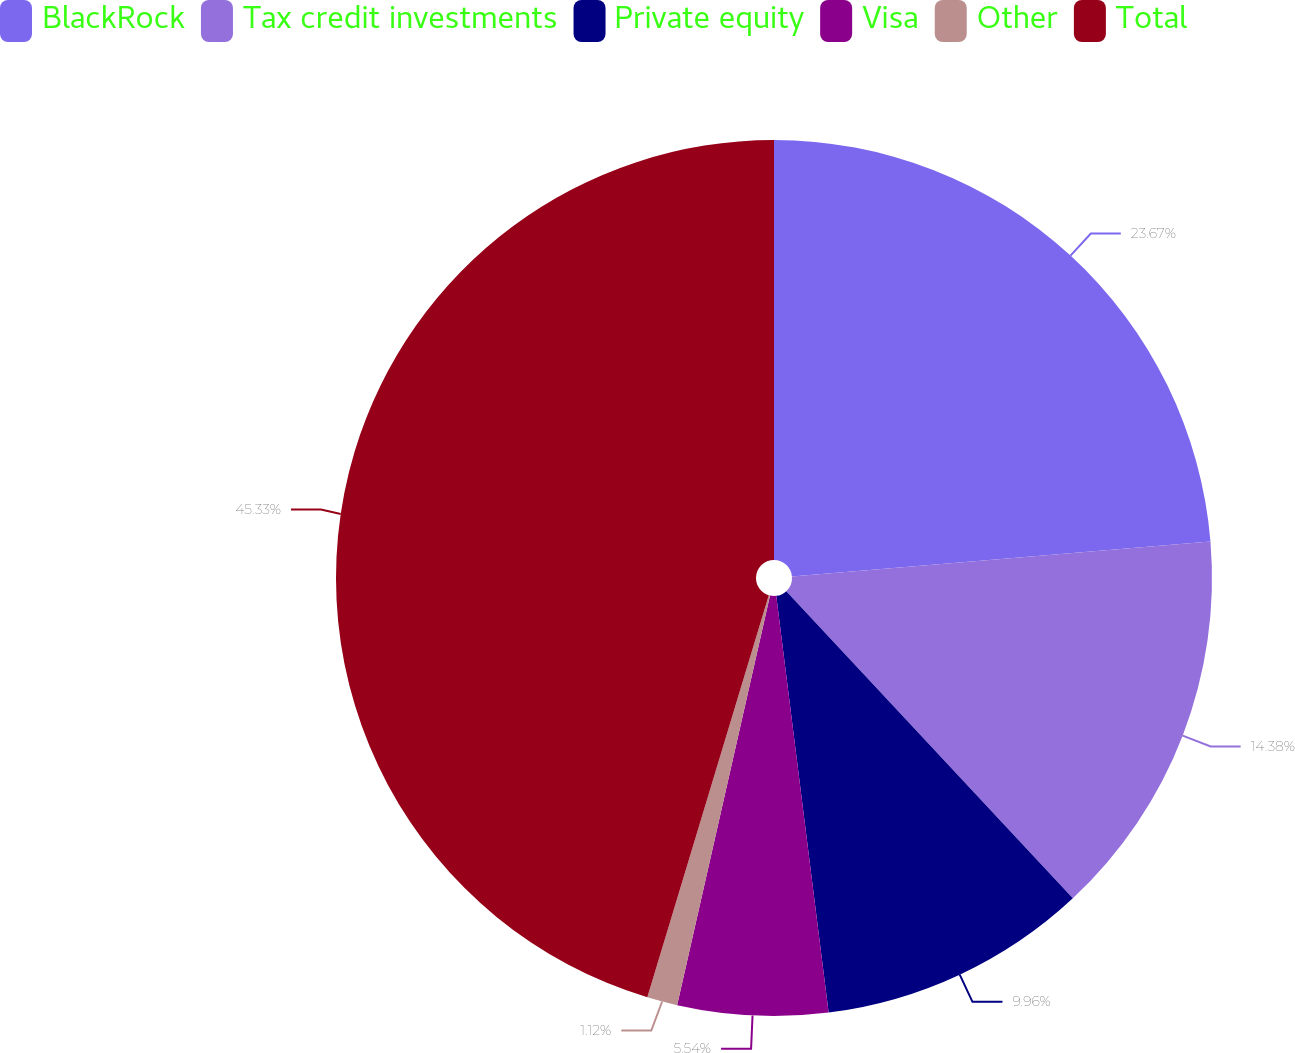Convert chart. <chart><loc_0><loc_0><loc_500><loc_500><pie_chart><fcel>BlackRock<fcel>Tax credit investments<fcel>Private equity<fcel>Visa<fcel>Other<fcel>Total<nl><fcel>23.67%<fcel>14.38%<fcel>9.96%<fcel>5.54%<fcel>1.12%<fcel>45.33%<nl></chart> 